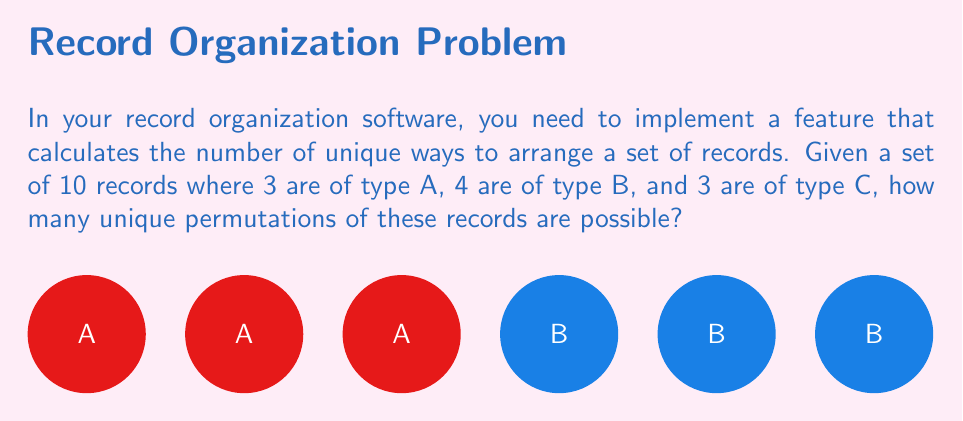Can you solve this math problem? To solve this problem, we need to use the concept of permutations with repetition. The formula for the number of unique permutations of $n$ objects where there are $n_1$ objects of type 1, $n_2$ objects of type 2, ..., and $n_k$ objects of type $k$ is:

$$\frac{n!}{n_1! \cdot n_2! \cdot ... \cdot n_k!}$$

In our case:
- Total number of records, $n = 10$
- Number of type A records, $n_1 = 3$
- Number of type B records, $n_2 = 4$
- Number of type C records, $n_3 = 3$

Substituting these values into the formula:

$$\text{Number of unique permutations} = \frac{10!}{3! \cdot 4! \cdot 3!}$$

Now, let's calculate this step by step:

1) First, calculate the numerator:
   $10! = 3,628,800$

2) Then, calculate the denominator:
   $3! = 6$
   $4! = 24$
   $3! = 6$
   $3! \cdot 4! \cdot 3! = 6 \cdot 24 \cdot 6 = 864$

3) Finally, divide the numerator by the denominator:
   $\frac{3,628,800}{864} = 4,200$

Therefore, there are 4,200 unique permutations of these records.
Answer: 4,200 